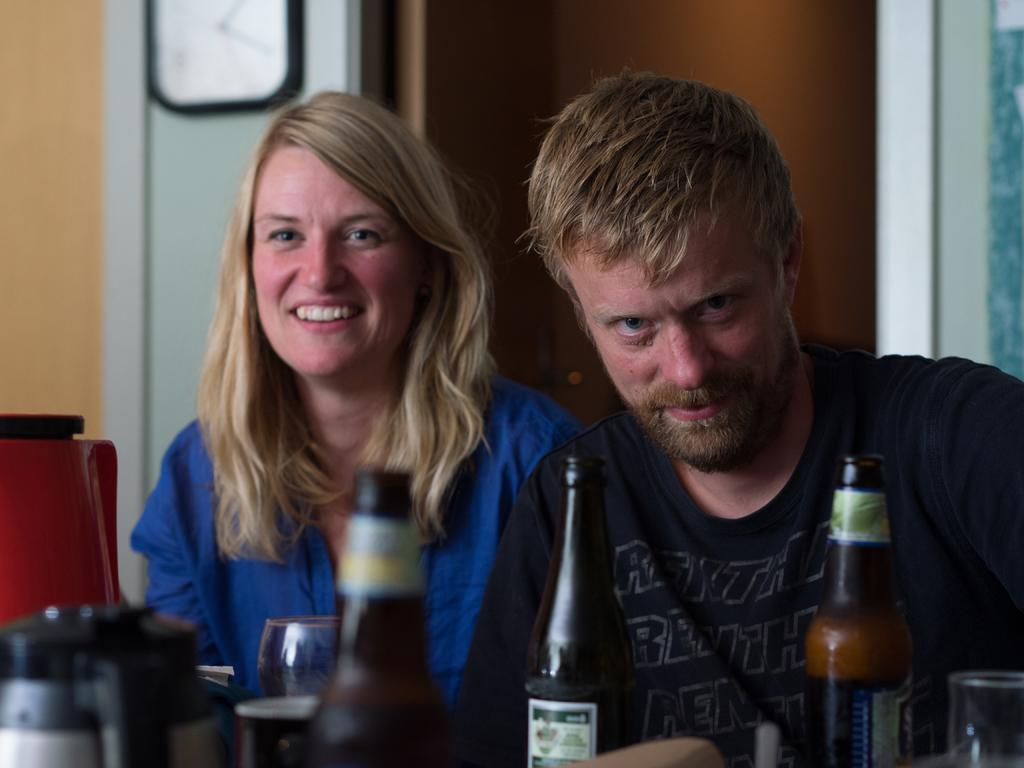How many people are present in the image? There are two persons standing in the image. What can be seen in the front of the image? There are bottles in the front of the image. What type of building is visible in the background of the image? There is no building visible in the background of the image. How do the persons in the image move around? The persons in the image are not moving; they are standing still. 